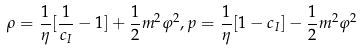<formula> <loc_0><loc_0><loc_500><loc_500>\rho = \frac { 1 } { \eta } [ \frac { 1 } { c _ { I } } - 1 ] + \frac { 1 } { 2 } m ^ { 2 } \varphi ^ { 2 } , p = \frac { 1 } { \eta } [ 1 - c _ { I } ] - \frac { 1 } { 2 } m ^ { 2 } \varphi ^ { 2 }</formula> 